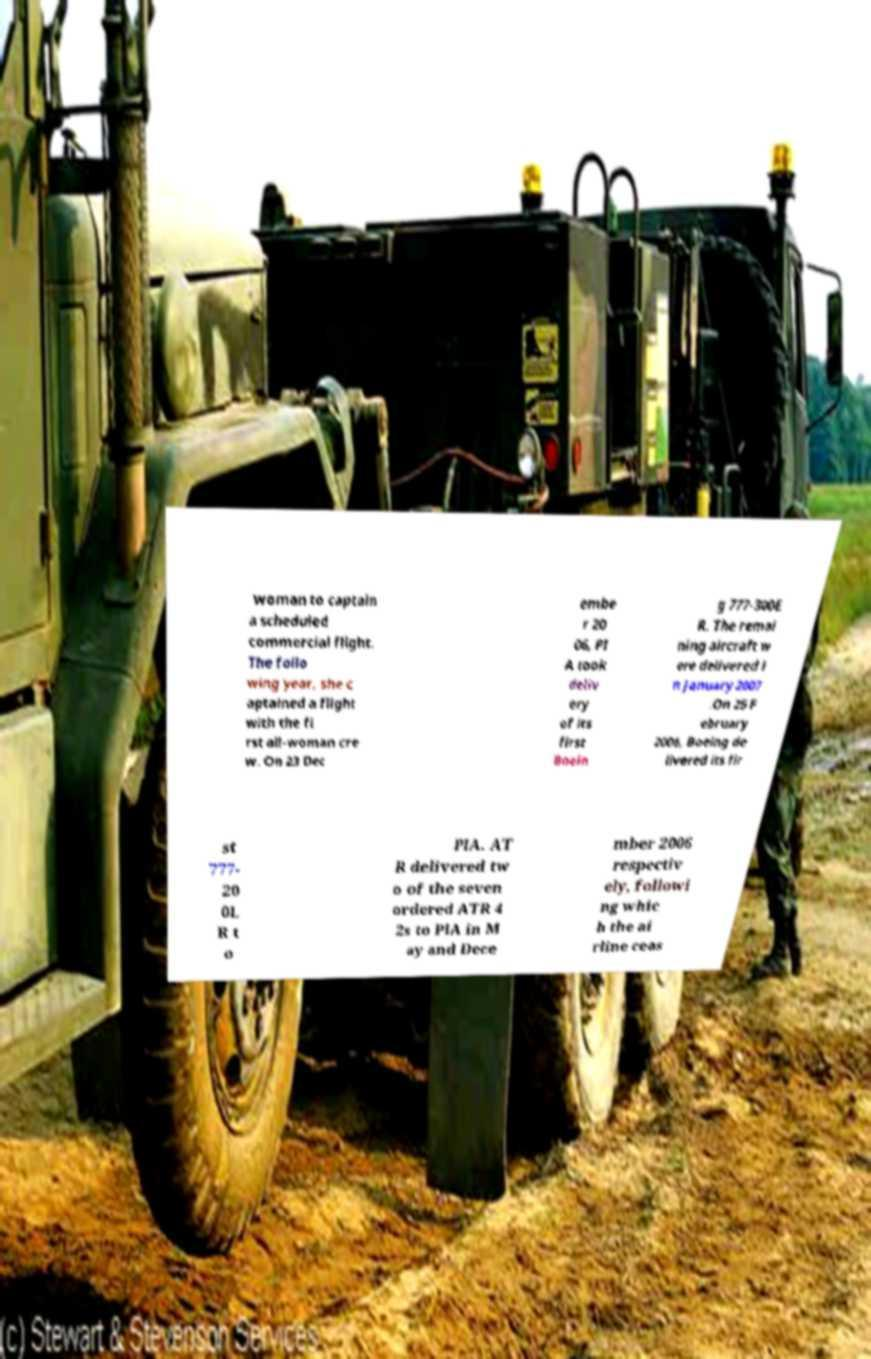For documentation purposes, I need the text within this image transcribed. Could you provide that? woman to captain a scheduled commercial flight. The follo wing year, she c aptained a flight with the fi rst all-woman cre w. On 23 Dec embe r 20 06, PI A took deliv ery of its first Boein g 777-300E R. The remai ning aircraft w ere delivered i n January 2007 .On 25 F ebruary 2006, Boeing de livered its fir st 777- 20 0L R t o PIA. AT R delivered tw o of the seven ordered ATR 4 2s to PIA in M ay and Dece mber 2006 respectiv ely, followi ng whic h the ai rline ceas 